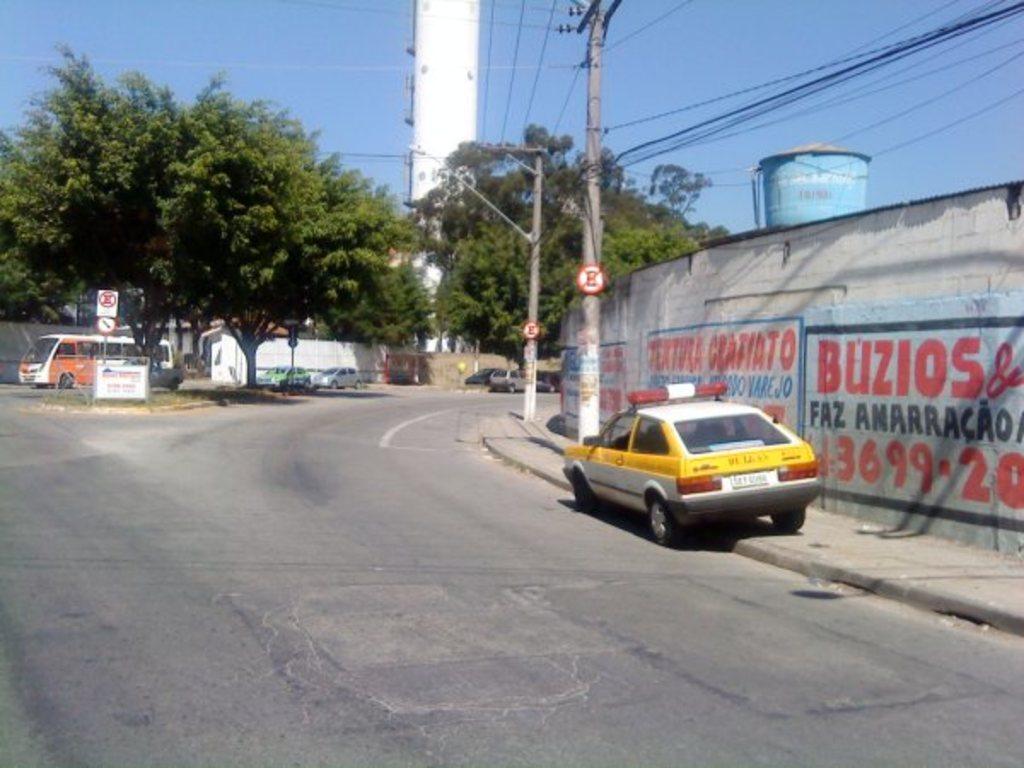What is one of the numbers on the wall?
Your response must be concise. 3699. 